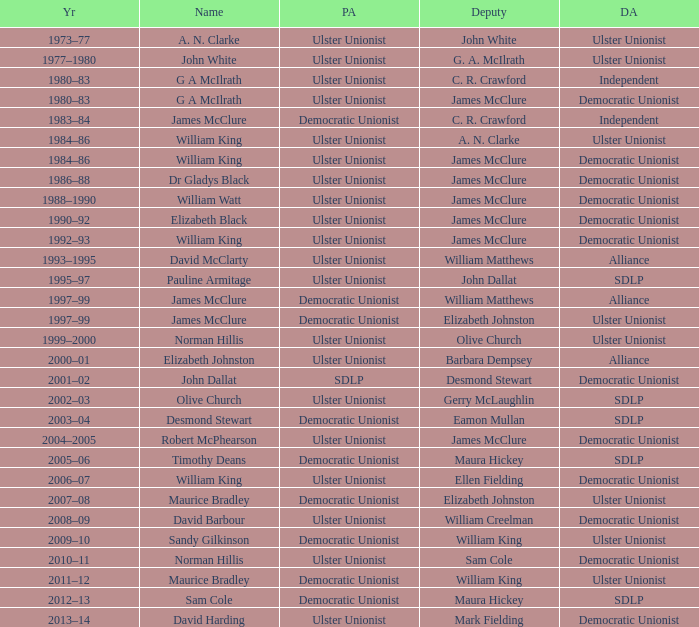What is the Political affiliation of deputy john dallat? Ulster Unionist. 